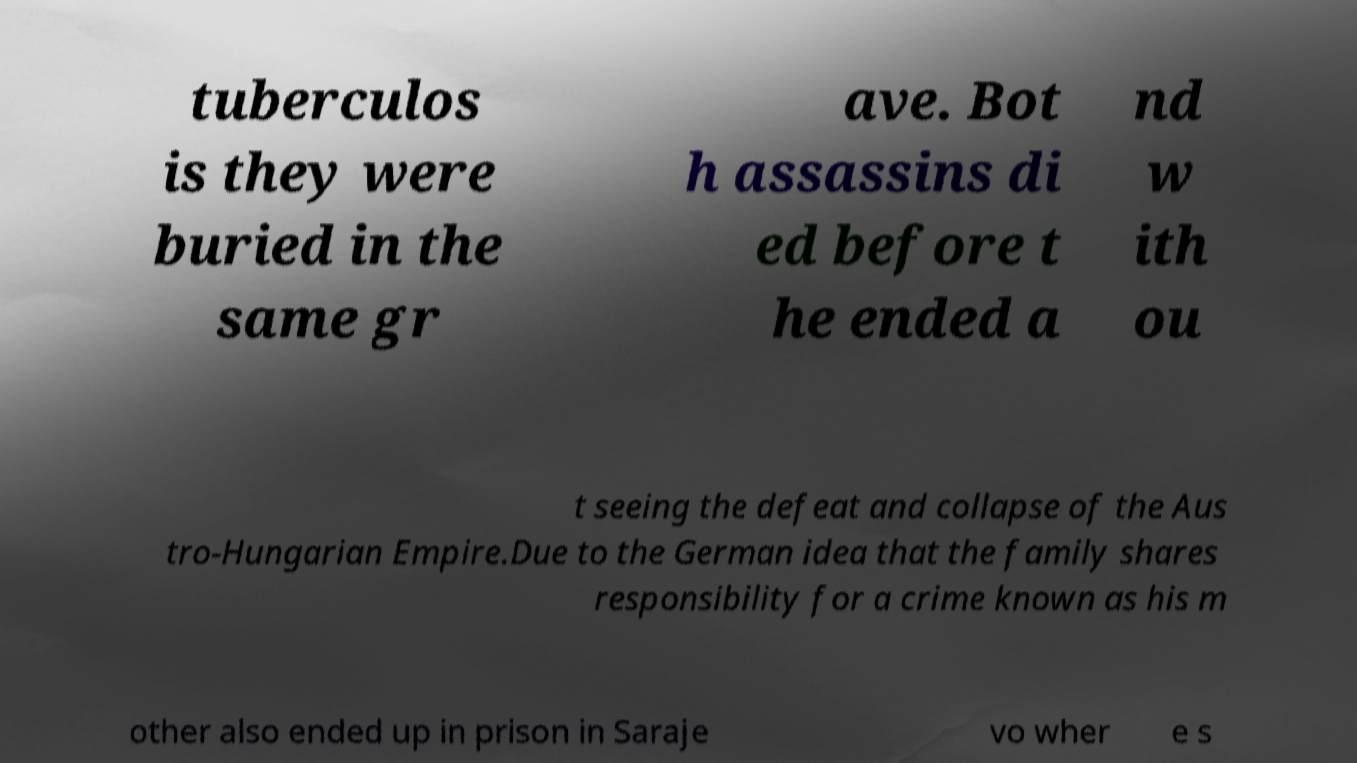Could you assist in decoding the text presented in this image and type it out clearly? tuberculos is they were buried in the same gr ave. Bot h assassins di ed before t he ended a nd w ith ou t seeing the defeat and collapse of the Aus tro-Hungarian Empire.Due to the German idea that the family shares responsibility for a crime known as his m other also ended up in prison in Saraje vo wher e s 